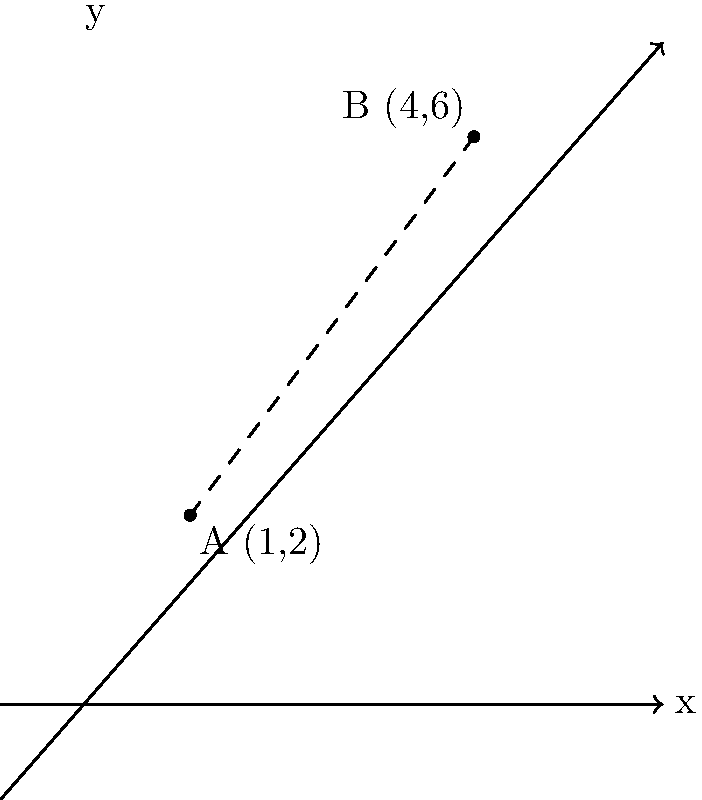In a project management scenario, you need to calculate the direct distance between two milestones represented as points on a coordinate plane. Given point A (1,2) representing the start of a process improvement initiative and point B (4,6) representing its completion, what is the distance between these two points? Round your answer to two decimal places. To find the distance between two points on a coordinate plane, we can use the distance formula, which is derived from the Pythagorean theorem:

$$d = \sqrt{(x_2 - x_1)^2 + (y_2 - y_1)^2}$$

Where $(x_1, y_1)$ are the coordinates of the first point and $(x_2, y_2)$ are the coordinates of the second point.

Let's follow these steps:

1) Identify the coordinates:
   Point A: $(x_1, y_1) = (1, 2)$
   Point B: $(x_2, y_2) = (4, 6)$

2) Plug these values into the distance formula:
   $$d = \sqrt{(4 - 1)^2 + (6 - 2)^2}$$

3) Simplify the expressions inside the parentheses:
   $$d = \sqrt{3^2 + 4^2}$$

4) Calculate the squares:
   $$d = \sqrt{9 + 16}$$

5) Add under the square root:
   $$d = \sqrt{25}$$

6) Calculate the square root:
   $$d = 5$$

Therefore, the distance between points A and B is 5 units.
Answer: 5 units 